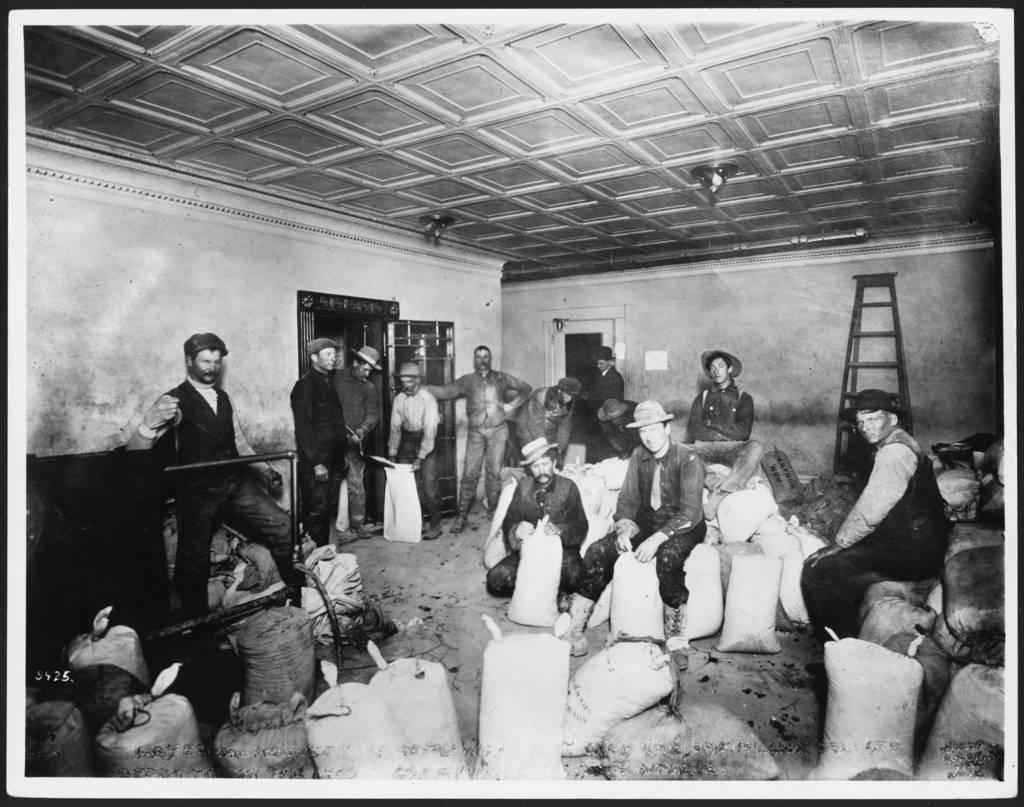What type of space is depicted in the image? There is a room in the image. How many people are present in the room? There are many people in the room. What type of wheel is being used by the beginner in the image? There is no wheel or beginner present in the image; it only shows a room with many people. 